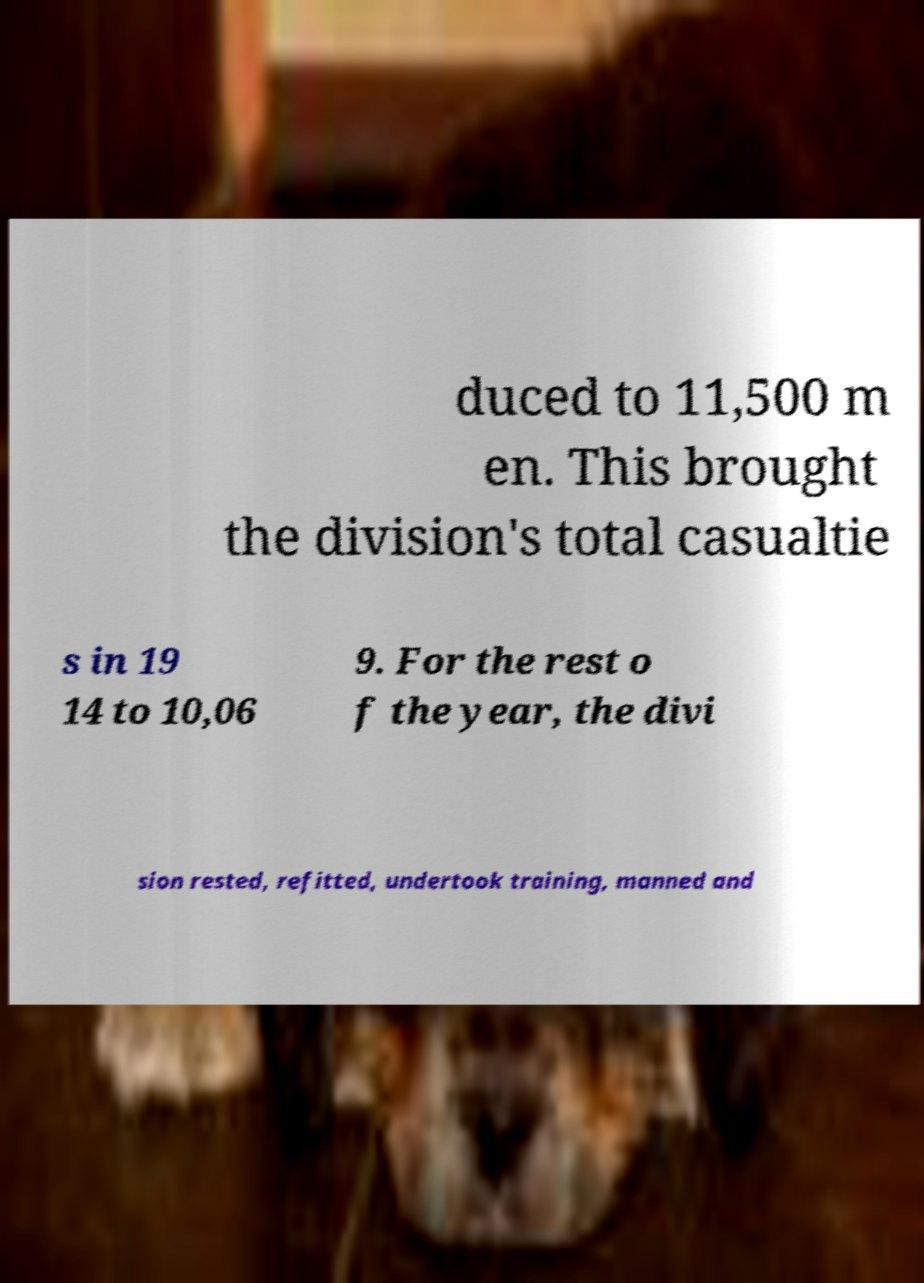Please identify and transcribe the text found in this image. duced to 11,500 m en. This brought the division's total casualtie s in 19 14 to 10,06 9. For the rest o f the year, the divi sion rested, refitted, undertook training, manned and 